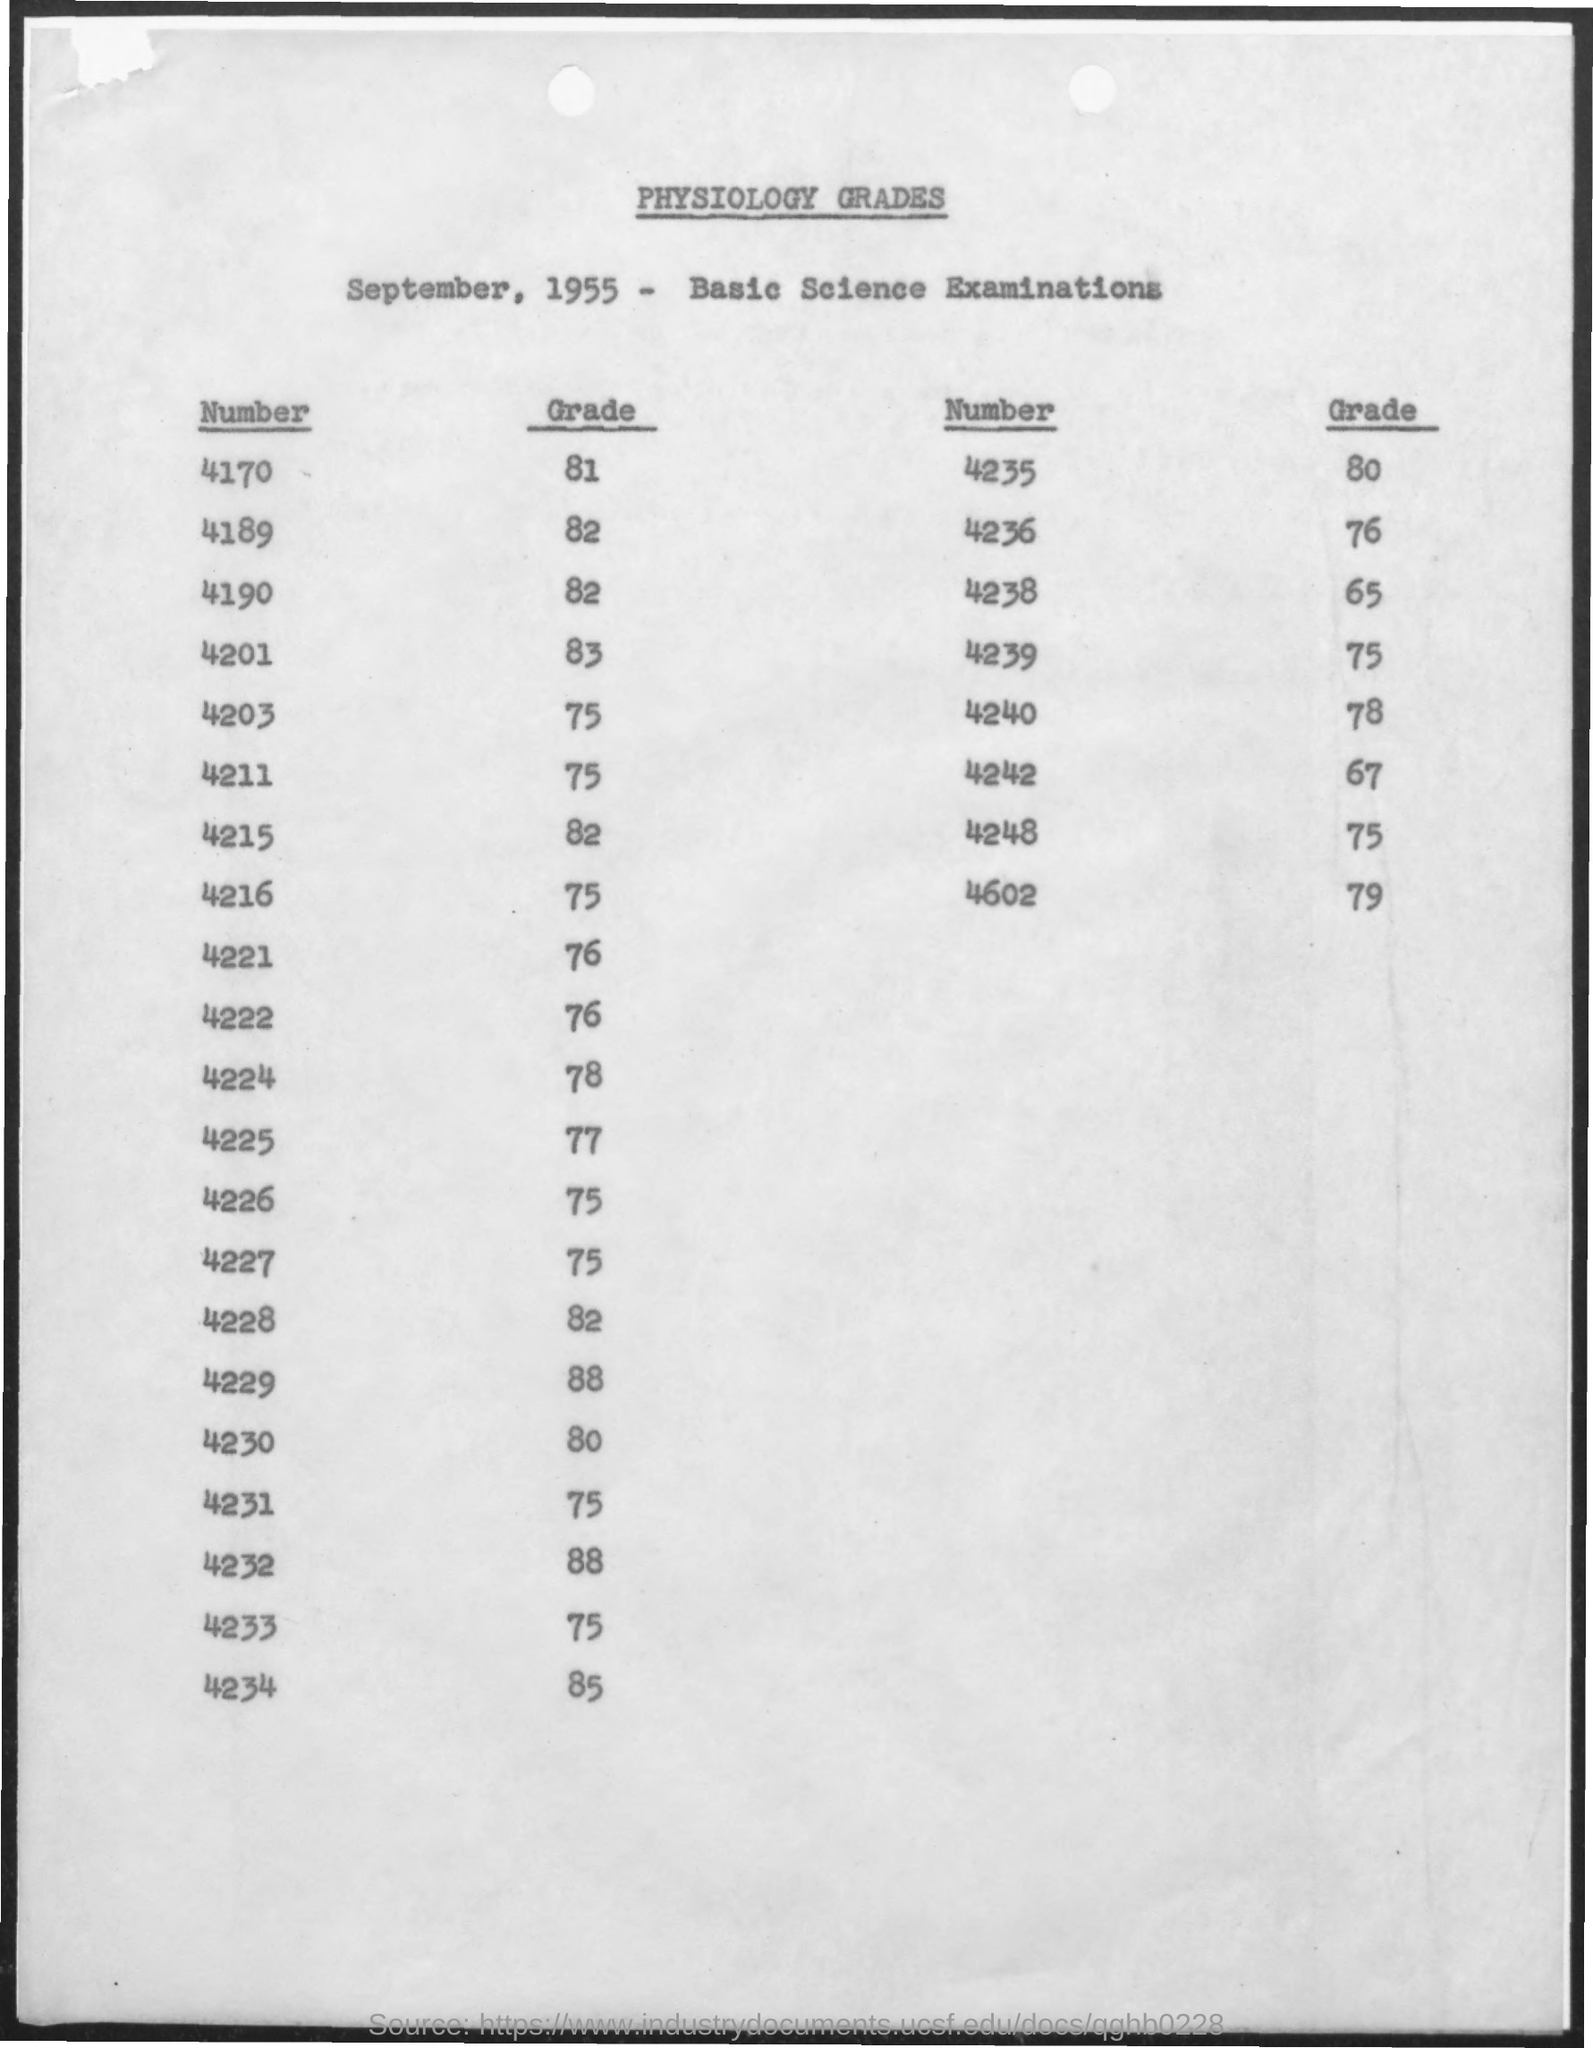Point out several critical features in this image. The heading is 'What is physiology grades?' The examination is the basic science examination. The grade of the number 4170 is 81. The year mentioned is 1955. 